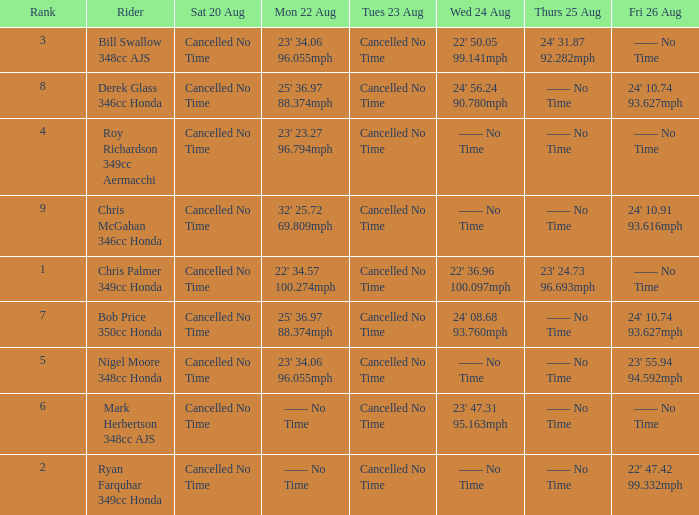What is every entry for Tuesday August 23 when Thursday August 25 is 24' 31.87 92.282mph? Cancelled No Time. 